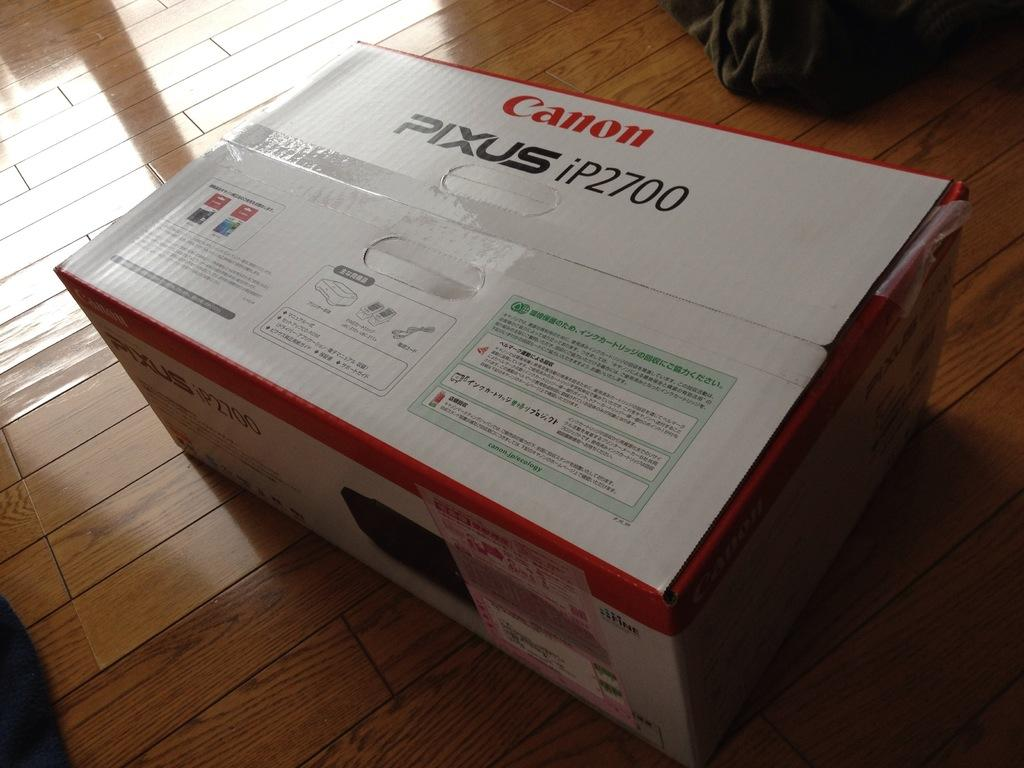<image>
Summarize the visual content of the image. A box that holds a Canon Pixus iP2700 is sitting on a wooden floor. 